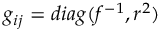Convert formula to latex. <formula><loc_0><loc_0><loc_500><loc_500>g _ { i j } = d i a g ( f ^ { - 1 } , r ^ { 2 } )</formula> 